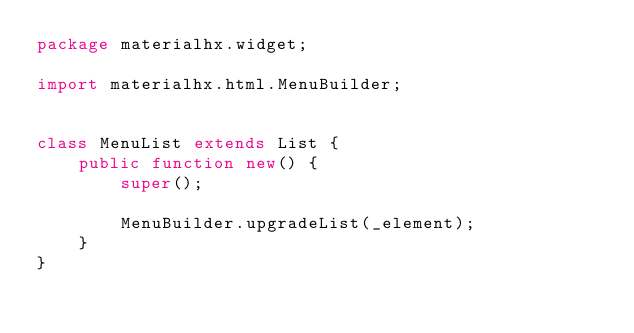<code> <loc_0><loc_0><loc_500><loc_500><_Haxe_>package materialhx.widget;

import materialhx.html.MenuBuilder;


class MenuList extends List {
    public function new() {
        super();

        MenuBuilder.upgradeList(_element);
    }
}
</code> 